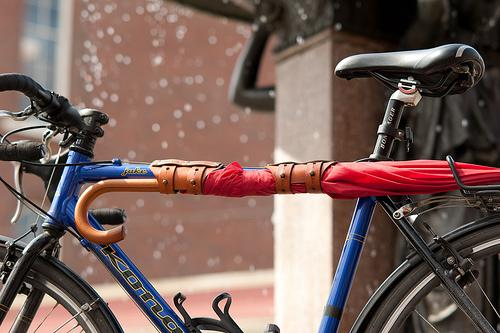Question: what color is the majority of the umbrella?
Choices:
A. Teal.
B. Red.
C. Purple.
D. Neon.
Answer with the letter. Answer: B Question: what are the first four characters on the bike?
Choices:
A. Eats.
B. Kono.
C. Road.
D. Hond.
Answer with the letter. Answer: B Question: what color is the bike tire?
Choices:
A. Black.
B. Teal.
C. Purple.
D. Neon.
Answer with the letter. Answer: A Question: how many wheels are visible?
Choices:
A. 12.
B. 13.
C. 2.
D. 5.
Answer with the letter. Answer: C 